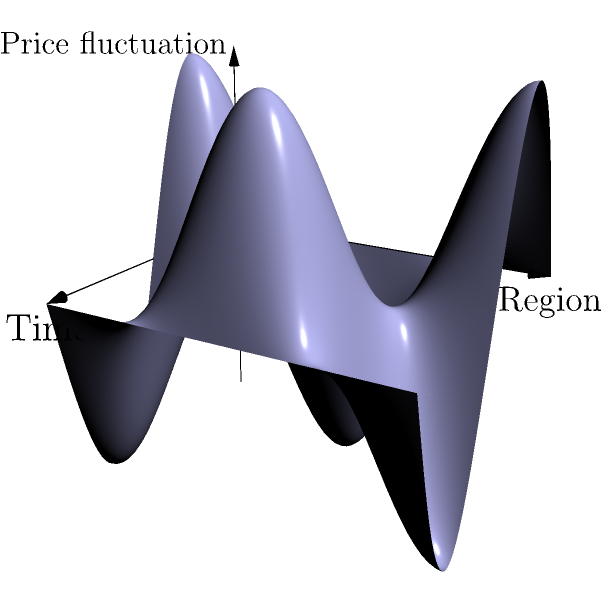Consider the surface shown in the graph, which represents the fluctuations in China's housing market prices over time and across different regions. If this surface is topologically equivalent to a torus with 2 handles, what is its Euler characteristic? To determine the Euler characteristic of this surface, we need to follow these steps:

1. Recall the formula for the Euler characteristic:
   $$\chi = V - E + F$$
   where $V$ is the number of vertices, $E$ is the number of edges, and $F$ is the number of faces.

2. For a torus with $g$ handles (genus $g$), the Euler characteristic is given by:
   $$\chi = 2 - 2g$$

3. In this case, we are told that the surface is topologically equivalent to a torus with 2 handles, so $g = 2$.

4. Substituting into the formula:
   $$\chi = 2 - 2(2) = 2 - 4 = -2$$

5. Therefore, the Euler characteristic of this surface is -2.

This result indicates that the China housing market price fluctuation surface, as represented, has a complex topology with multiple "holes" or cycles, which could correspond to periodic patterns or regional variations in the market over time.
Answer: -2 